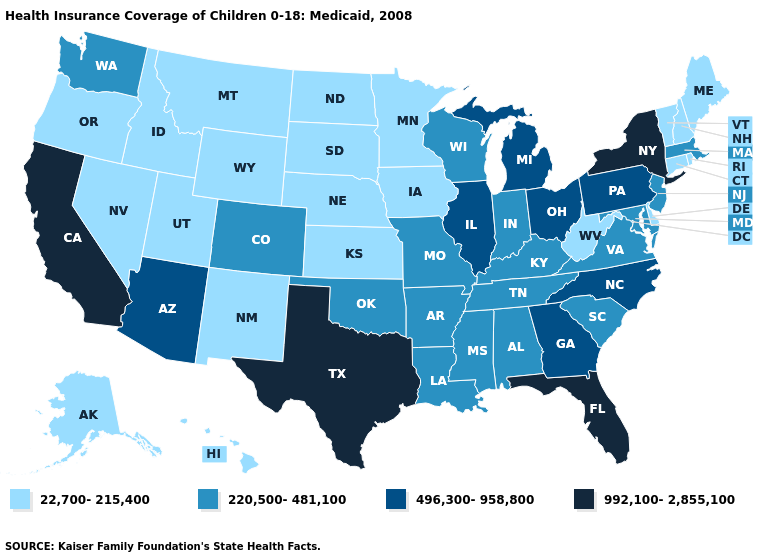Among the states that border Arizona , which have the highest value?
Concise answer only. California. How many symbols are there in the legend?
Write a very short answer. 4. Name the states that have a value in the range 22,700-215,400?
Be succinct. Alaska, Connecticut, Delaware, Hawaii, Idaho, Iowa, Kansas, Maine, Minnesota, Montana, Nebraska, Nevada, New Hampshire, New Mexico, North Dakota, Oregon, Rhode Island, South Dakota, Utah, Vermont, West Virginia, Wyoming. Which states have the lowest value in the South?
Short answer required. Delaware, West Virginia. Does the map have missing data?
Be succinct. No. What is the value of Tennessee?
Concise answer only. 220,500-481,100. What is the value of Connecticut?
Short answer required. 22,700-215,400. Among the states that border Arizona , which have the lowest value?
Keep it brief. Nevada, New Mexico, Utah. What is the highest value in states that border Texas?
Keep it brief. 220,500-481,100. What is the value of Kentucky?
Give a very brief answer. 220,500-481,100. What is the value of California?
Give a very brief answer. 992,100-2,855,100. Name the states that have a value in the range 22,700-215,400?
Be succinct. Alaska, Connecticut, Delaware, Hawaii, Idaho, Iowa, Kansas, Maine, Minnesota, Montana, Nebraska, Nevada, New Hampshire, New Mexico, North Dakota, Oregon, Rhode Island, South Dakota, Utah, Vermont, West Virginia, Wyoming. What is the value of New Mexico?
Keep it brief. 22,700-215,400. Does Pennsylvania have a lower value than New Mexico?
Write a very short answer. No. 